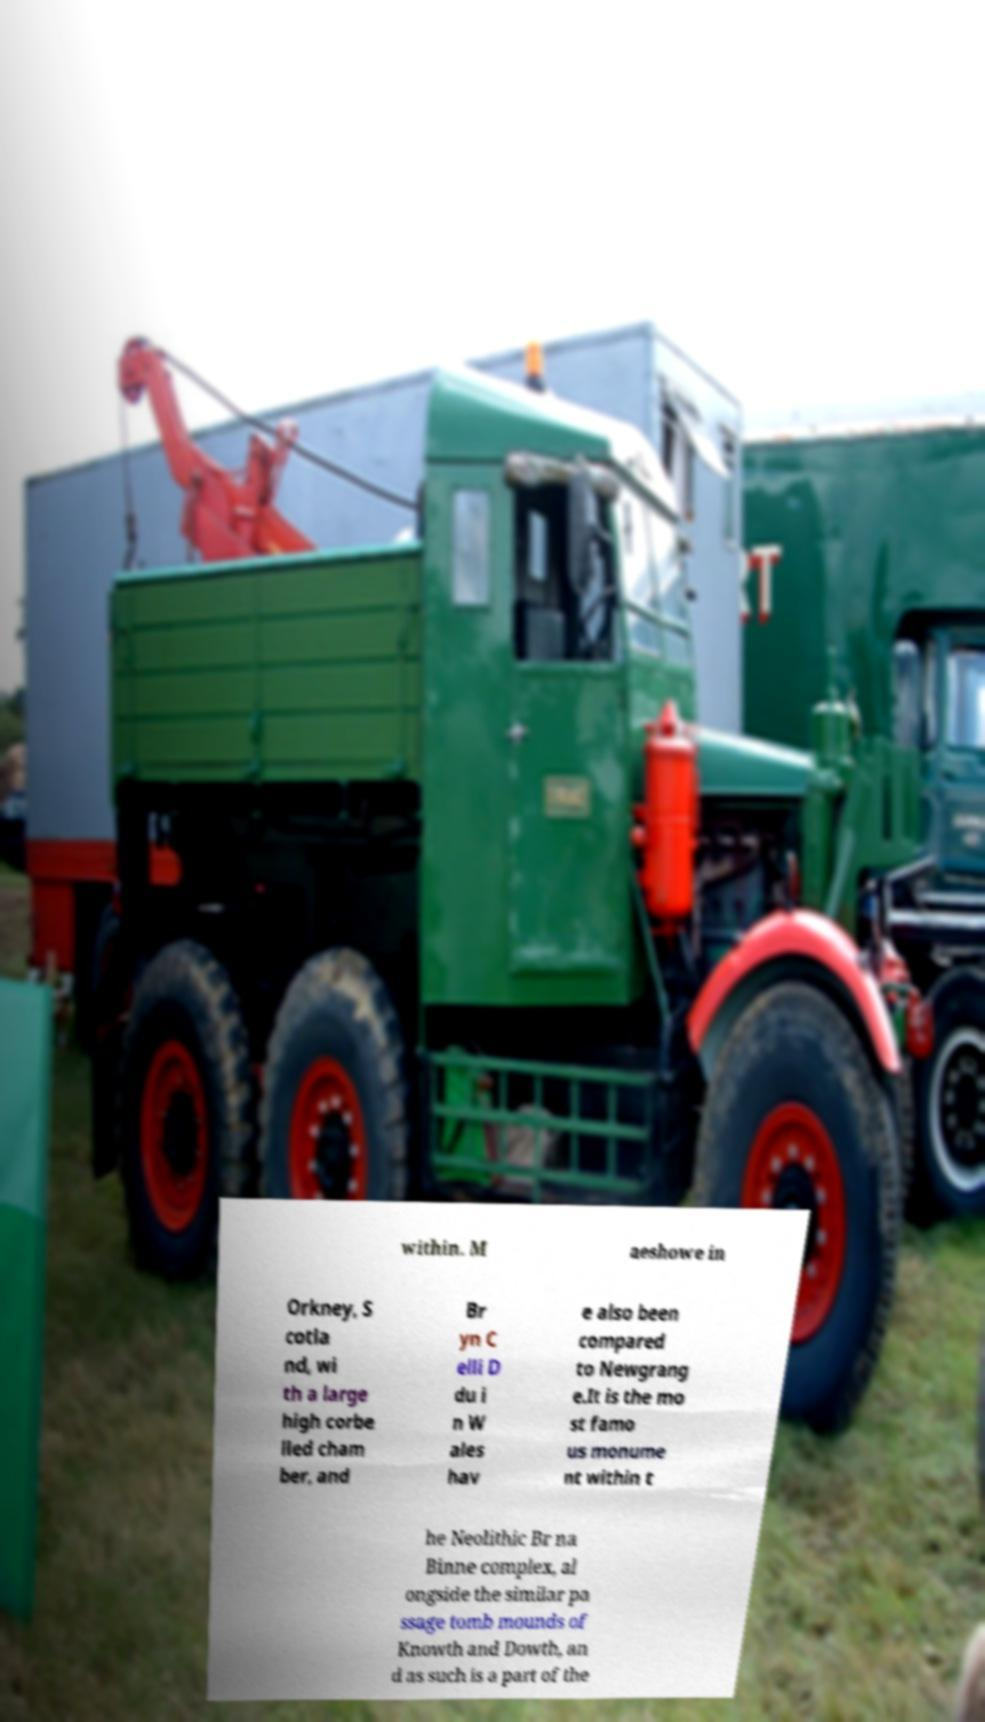For documentation purposes, I need the text within this image transcribed. Could you provide that? within. M aeshowe in Orkney, S cotla nd, wi th a large high corbe lled cham ber, and Br yn C elli D du i n W ales hav e also been compared to Newgrang e.It is the mo st famo us monume nt within t he Neolithic Br na Binne complex, al ongside the similar pa ssage tomb mounds of Knowth and Dowth, an d as such is a part of the 